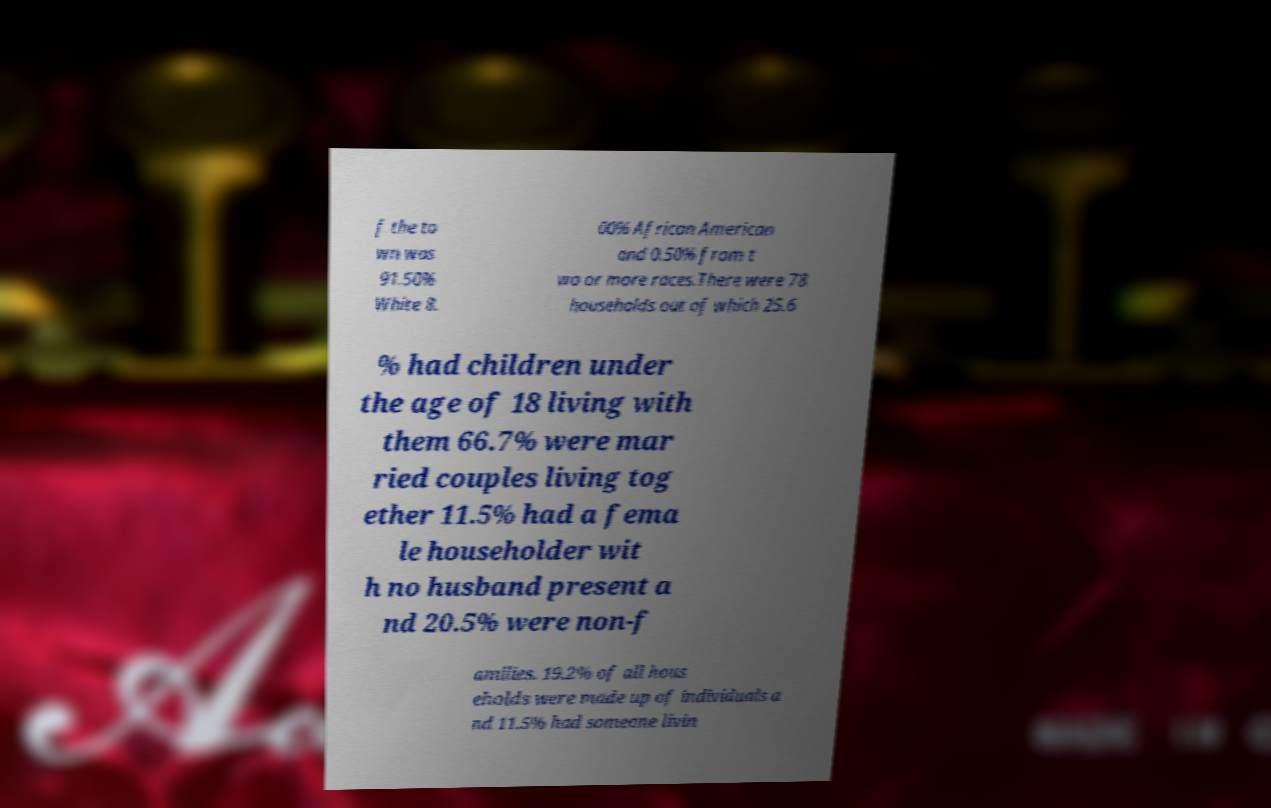There's text embedded in this image that I need extracted. Can you transcribe it verbatim? f the to wn was 91.50% White 8. 00% African American and 0.50% from t wo or more races.There were 78 households out of which 25.6 % had children under the age of 18 living with them 66.7% were mar ried couples living tog ether 11.5% had a fema le householder wit h no husband present a nd 20.5% were non-f amilies. 19.2% of all hous eholds were made up of individuals a nd 11.5% had someone livin 